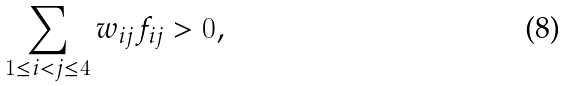Convert formula to latex. <formula><loc_0><loc_0><loc_500><loc_500>\sum _ { 1 \leq i < j \leq 4 } w _ { i j } f _ { i j } > 0 ,</formula> 